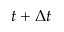Convert formula to latex. <formula><loc_0><loc_0><loc_500><loc_500>t + \Delta t</formula> 